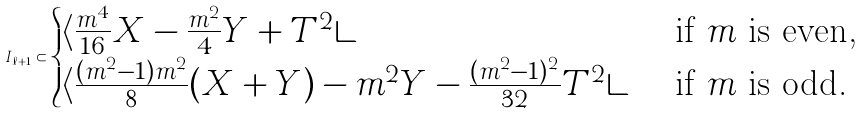<formula> <loc_0><loc_0><loc_500><loc_500>I _ { \ell + 1 } \subset \begin{cases} \langle \frac { m ^ { 4 } } { 1 6 } X - \frac { m ^ { 2 } } { 4 } Y + T ^ { 2 } \rangle & \text { if } m \text { is even,} \\ \langle \frac { ( m ^ { 2 } - 1 ) m ^ { 2 } } { 8 } ( X + Y ) - m ^ { 2 } Y - \frac { ( m ^ { 2 } - 1 ) ^ { 2 } } { 3 2 } T ^ { 2 } \rangle & \text { if } m \text { is odd.} \end{cases}</formula> 